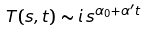Convert formula to latex. <formula><loc_0><loc_0><loc_500><loc_500>T ( s , t ) \sim i \, s ^ { \alpha _ { 0 } + \alpha ^ { \prime } t }</formula> 